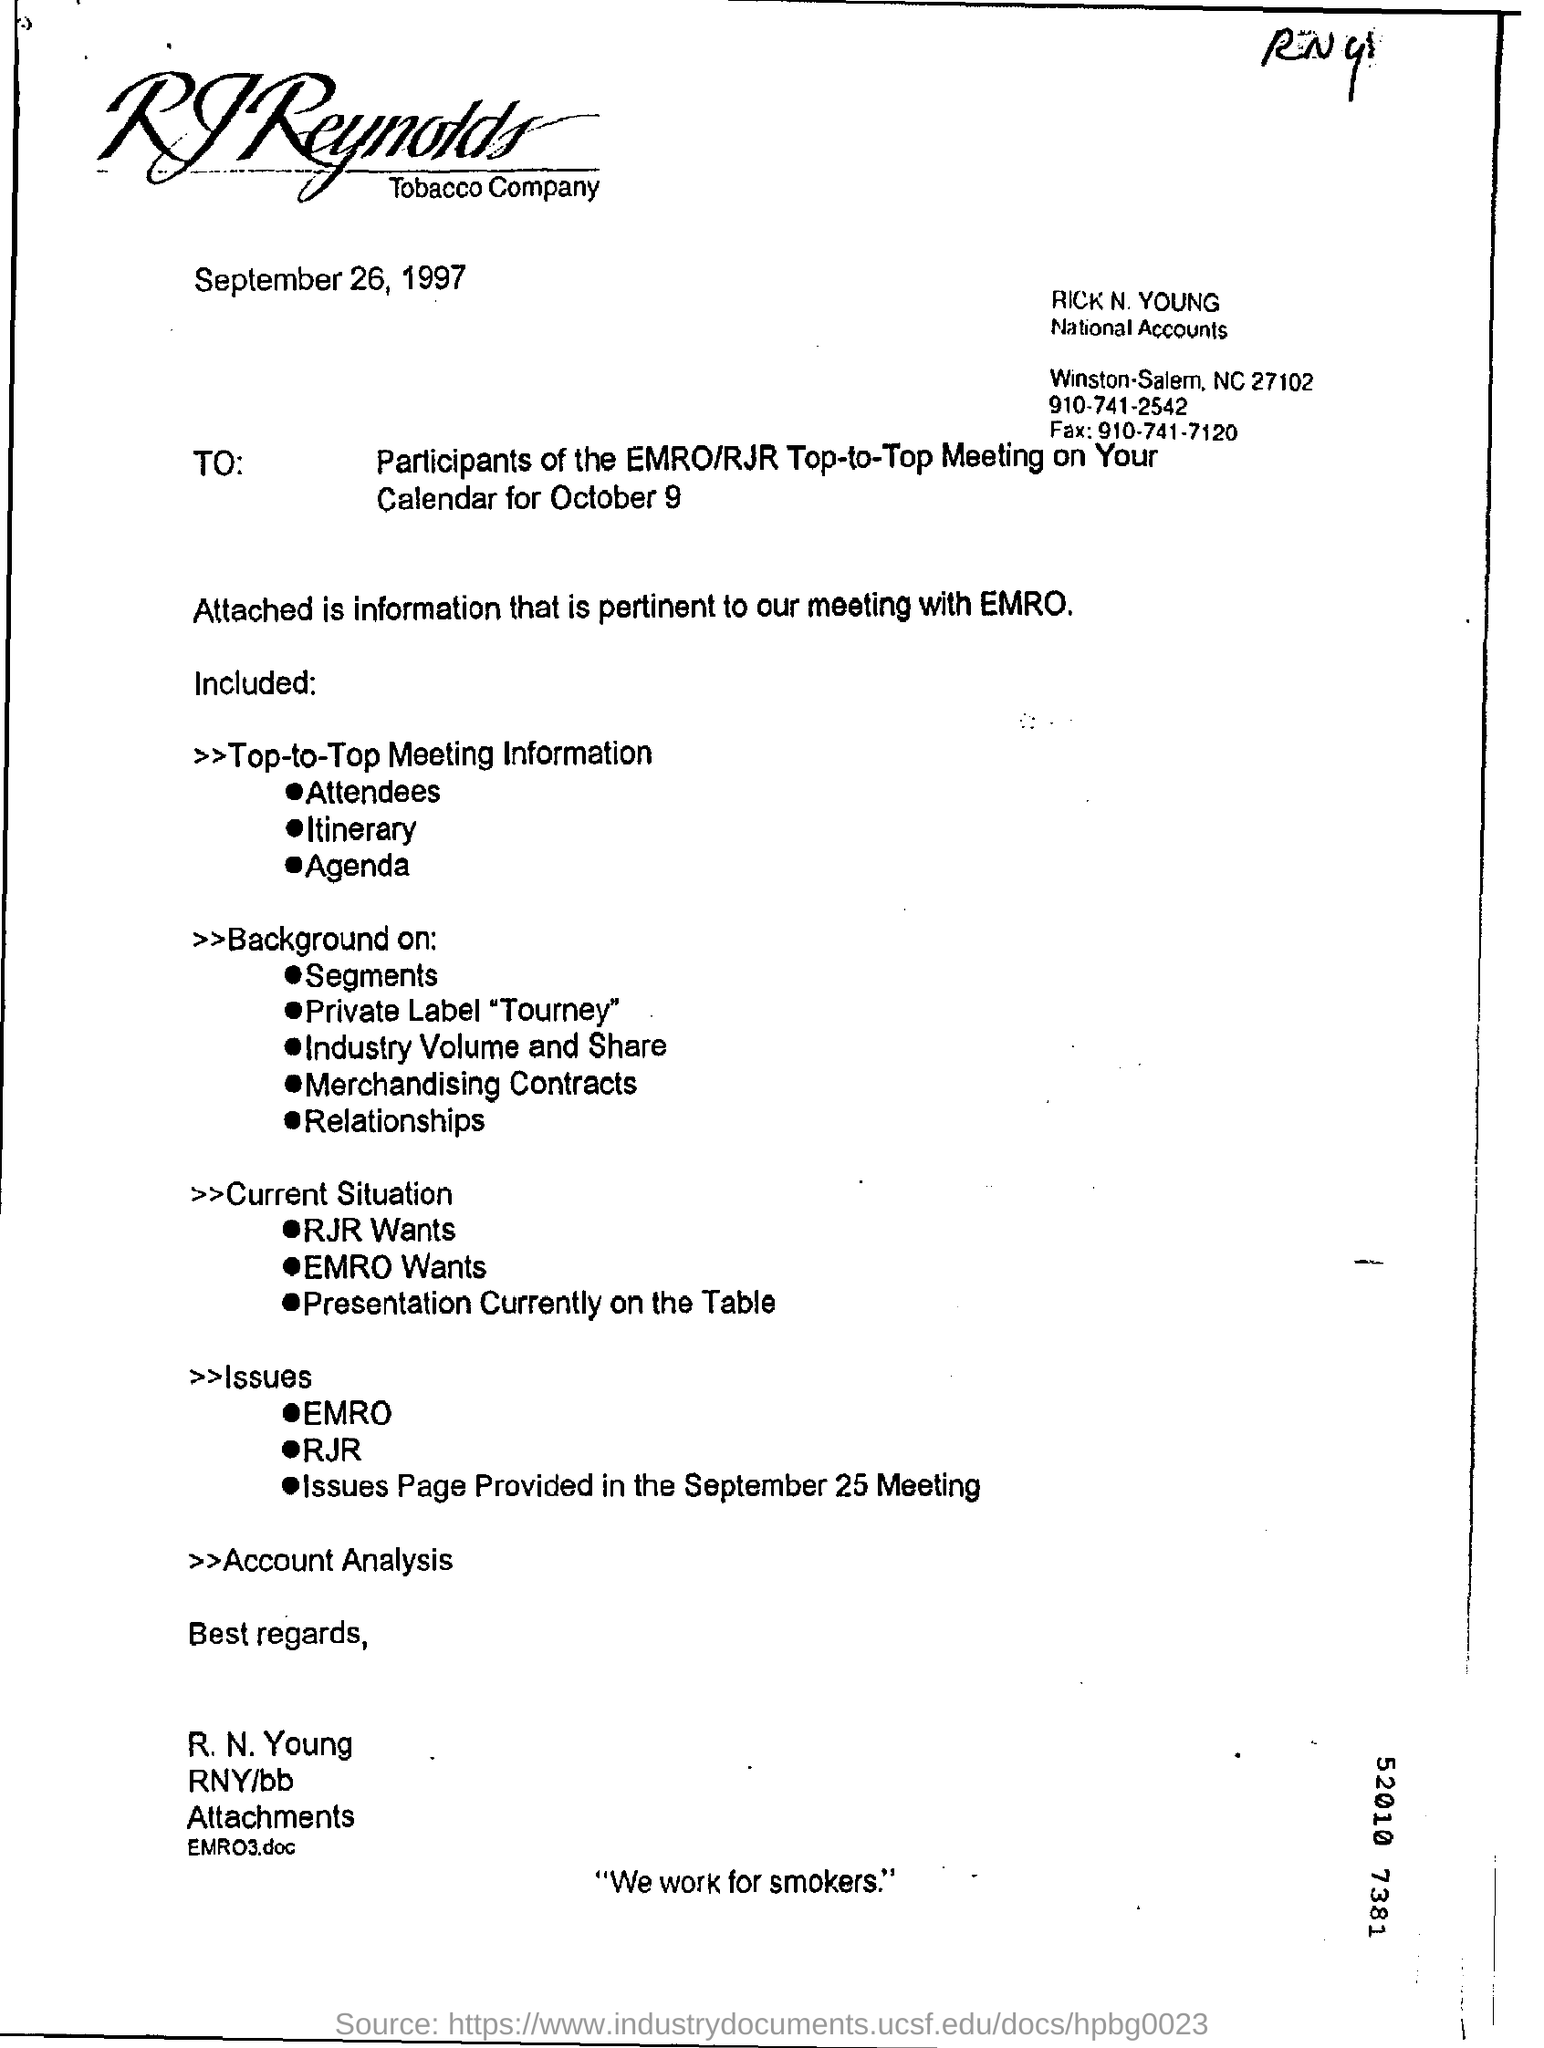Which file is attached?
Your response must be concise. EMRO3.doc. What is this letter dated?
Your answer should be very brief. September 26, 1997. Which company is mentioned in the letter head?
Keep it short and to the point. RJREYNOLDS. What is the fax no of Rick N. Young?
Your answer should be very brief. 910-741-7120. Who is the sender of this letter?
Your answer should be very brief. R.N. Young. 